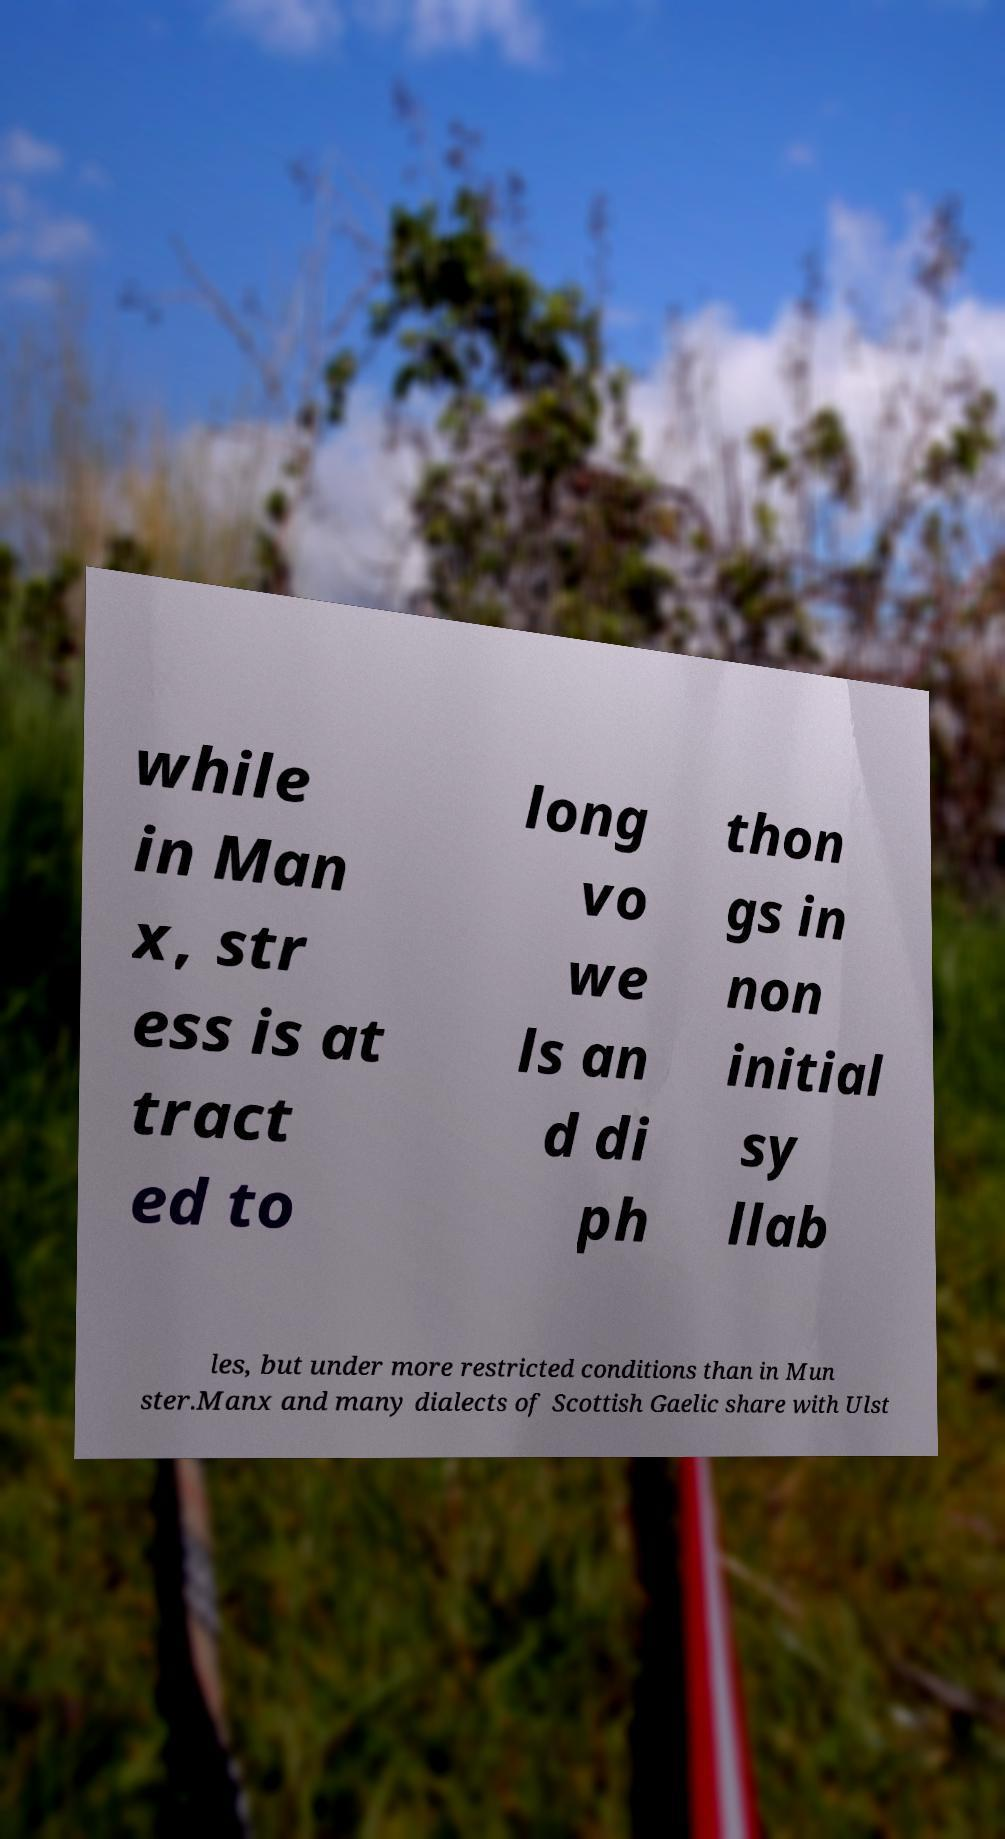Can you read and provide the text displayed in the image?This photo seems to have some interesting text. Can you extract and type it out for me? while in Man x, str ess is at tract ed to long vo we ls an d di ph thon gs in non initial sy llab les, but under more restricted conditions than in Mun ster.Manx and many dialects of Scottish Gaelic share with Ulst 